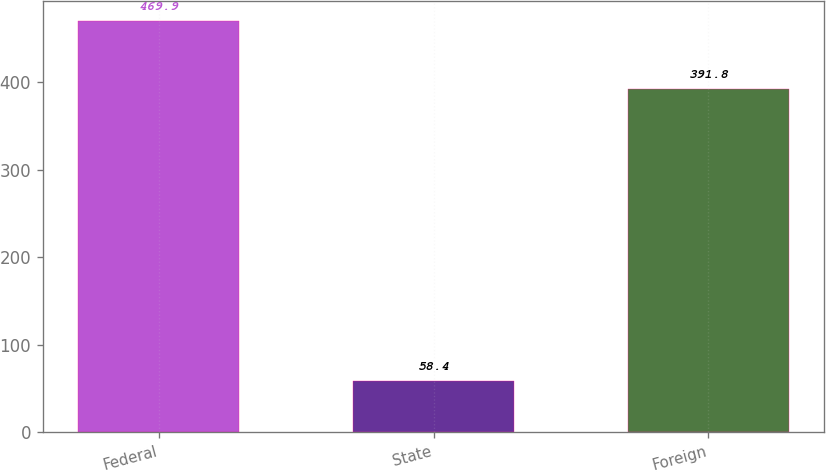<chart> <loc_0><loc_0><loc_500><loc_500><bar_chart><fcel>Federal<fcel>State<fcel>Foreign<nl><fcel>469.9<fcel>58.4<fcel>391.8<nl></chart> 